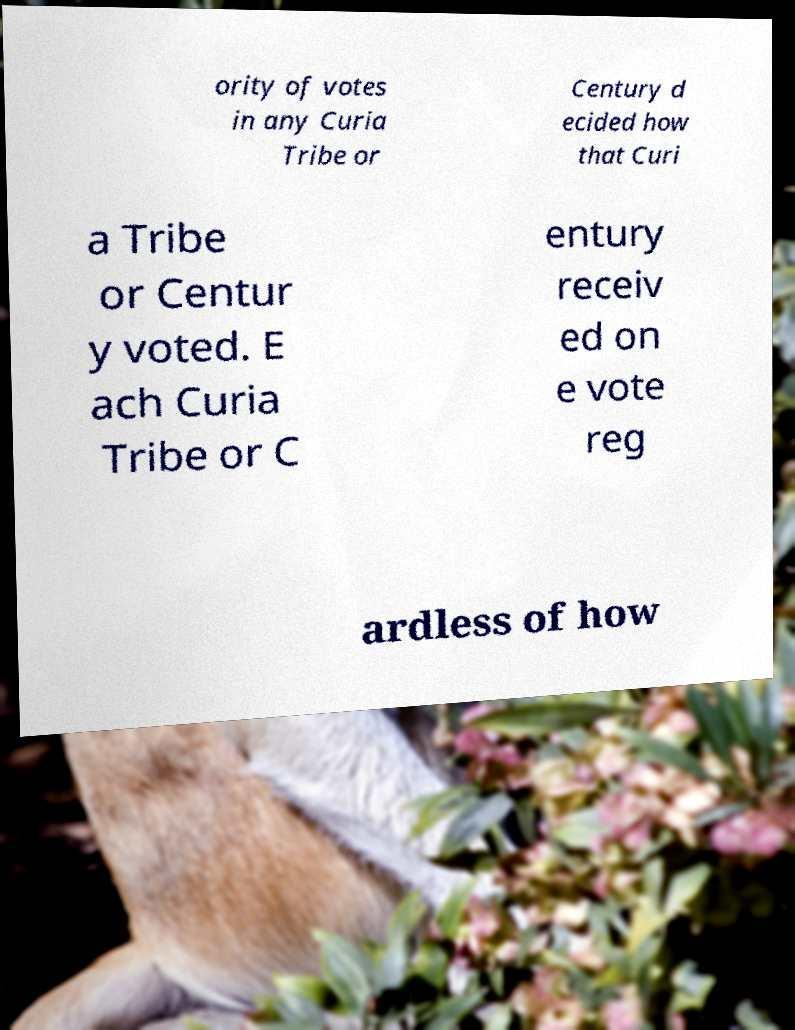For documentation purposes, I need the text within this image transcribed. Could you provide that? ority of votes in any Curia Tribe or Century d ecided how that Curi a Tribe or Centur y voted. E ach Curia Tribe or C entury receiv ed on e vote reg ardless of how 